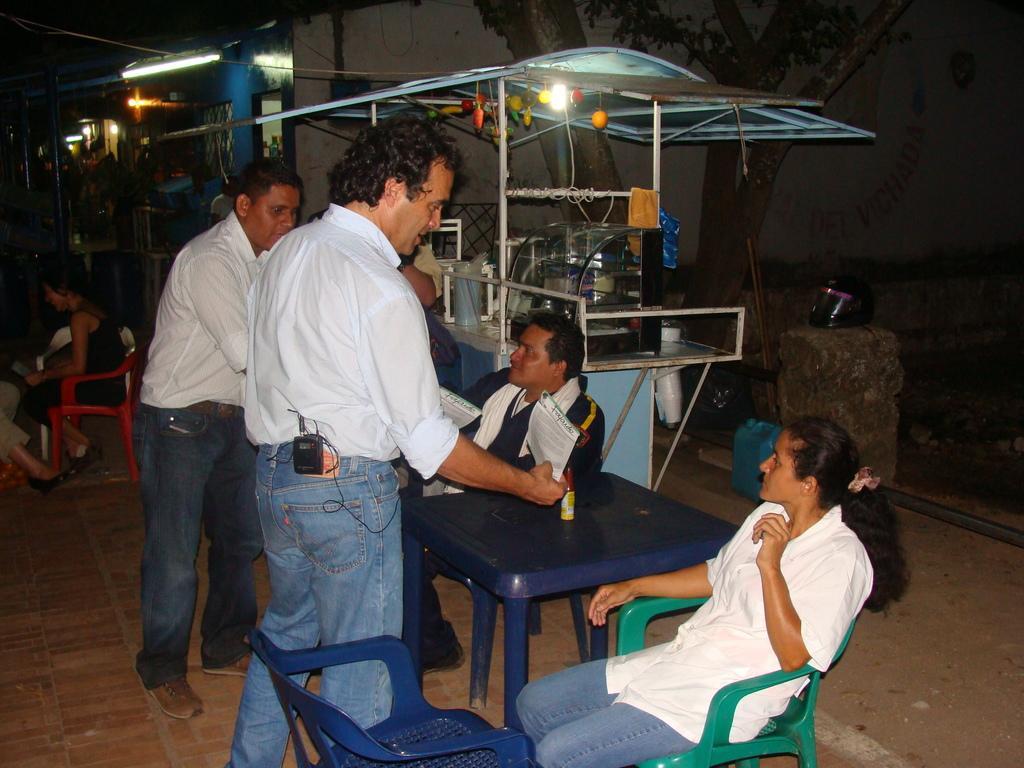In one or two sentences, can you explain what this image depicts? In this image I can see people where few of them are standing and rest all are sitting on chairs. In the background I can see a stall, a tree and a building. 